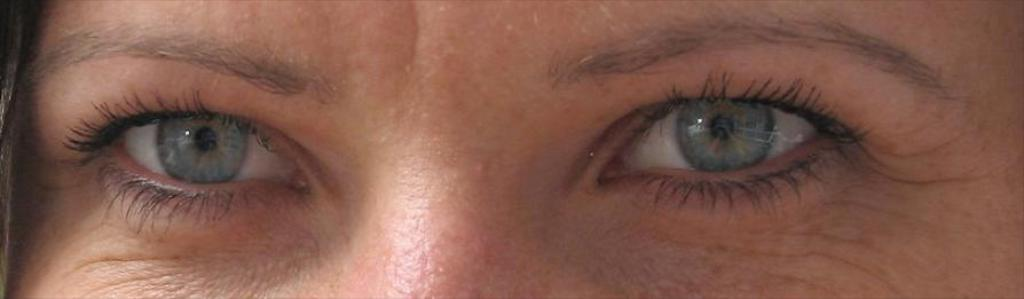What body part is depicted in the image? Human eyes are depicted in the image. What feature is present above the eyes in the image? There are eyebrows in the image. What type of plastic material can be seen melting in the image? There is no plastic material present in the image; it only features human eyes and eyebrows. 